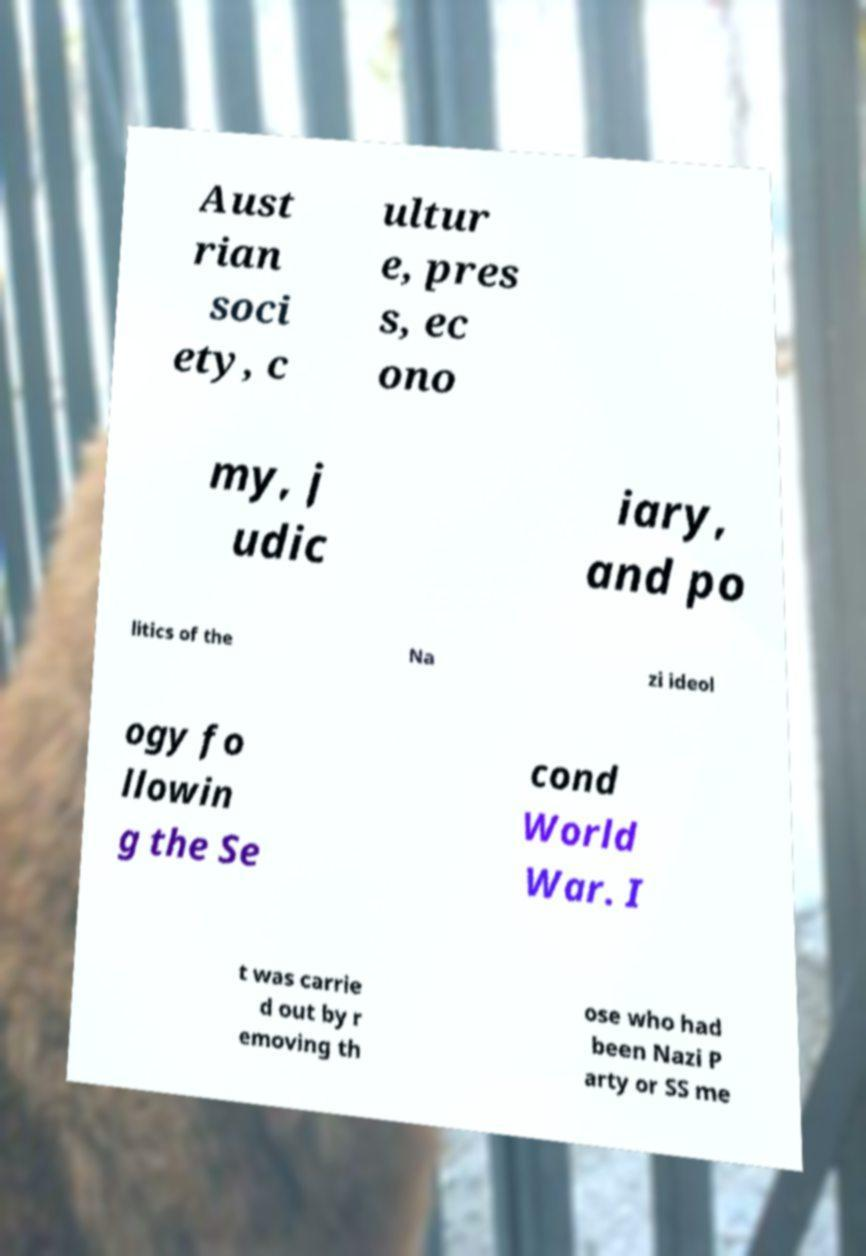What messages or text are displayed in this image? I need them in a readable, typed format. Aust rian soci ety, c ultur e, pres s, ec ono my, j udic iary, and po litics of the Na zi ideol ogy fo llowin g the Se cond World War. I t was carrie d out by r emoving th ose who had been Nazi P arty or SS me 